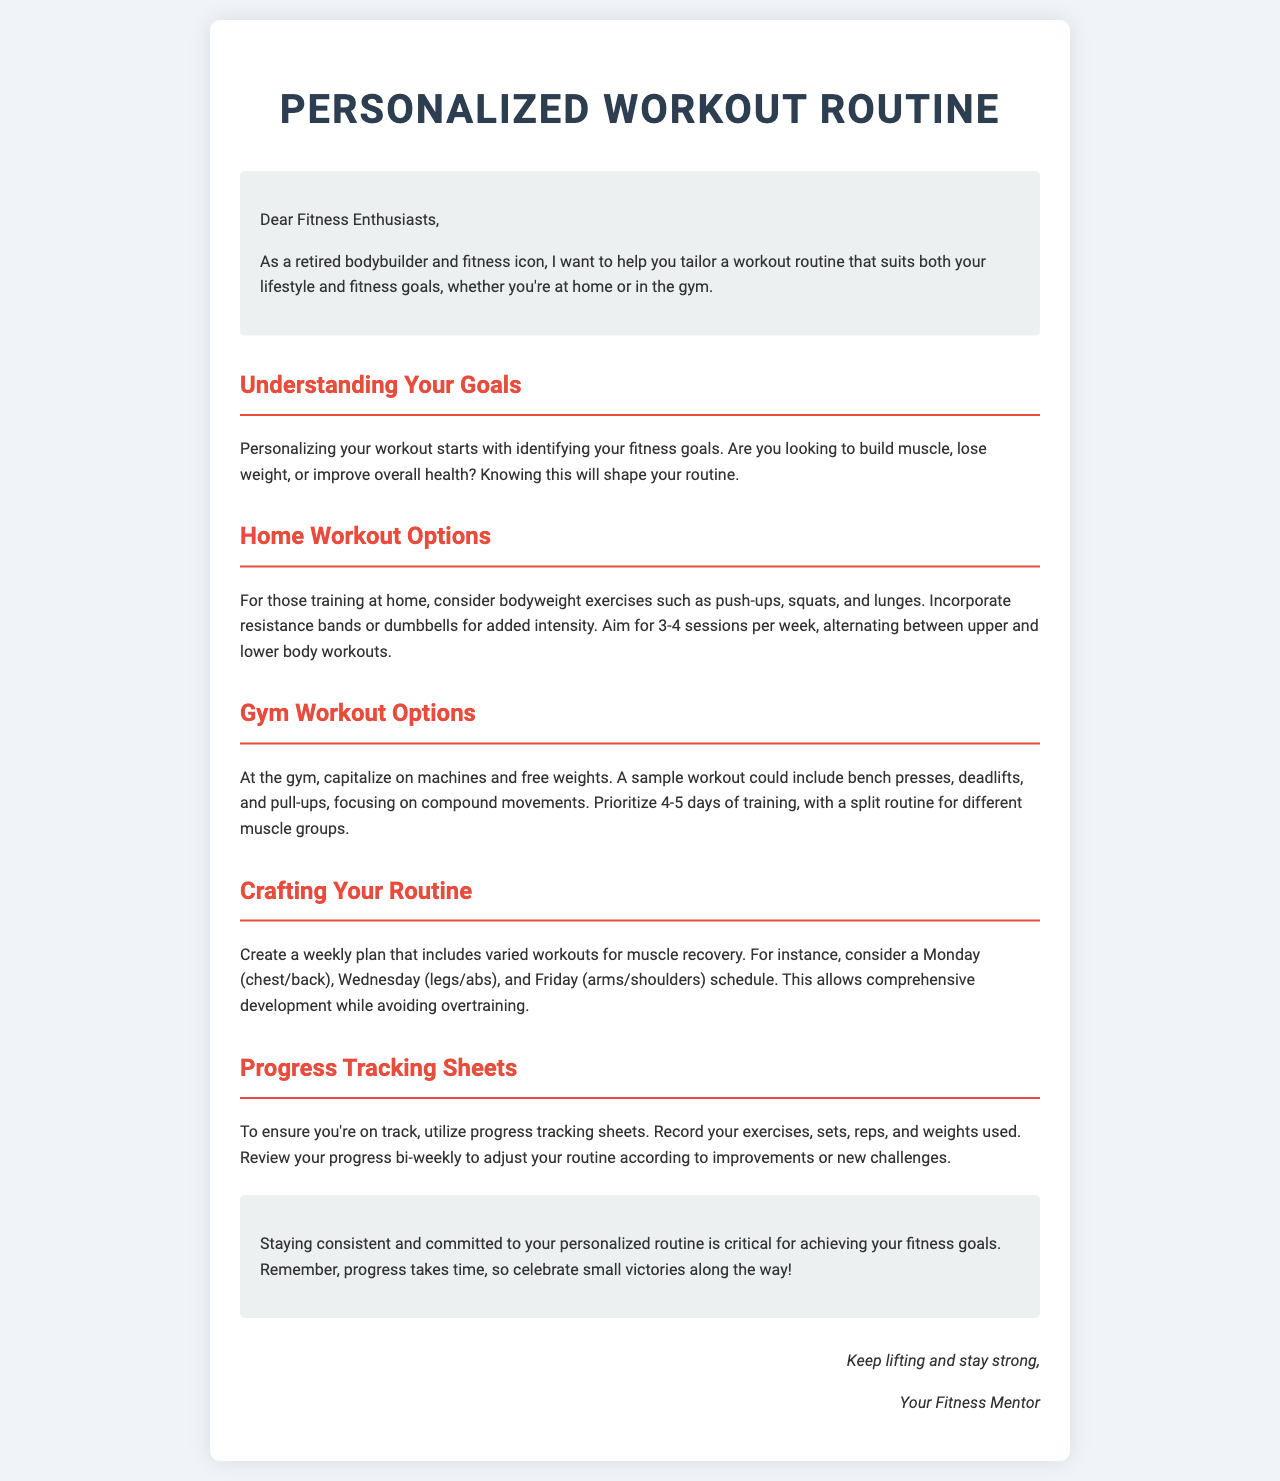What is the title of the document? The title of the document is provided in the header section of the HTML, which is "Personalized Workout Routine".
Answer: Personalized Workout Routine Who is the author of the letter? The author of the letter is mentioned in the signature, stating "Your Fitness Mentor".
Answer: Your Fitness Mentor How many days a week should you aim for home workouts? The document suggests aiming for 3-4 sessions per week for home workouts.
Answer: 3-4 What type of exercises are recommended for home workouts? The document lists bodyweight exercises such as push-ups, squats, and lunges as examples.
Answer: Bodyweight exercises What is a sample workout suggested for the gym? The document suggests bench presses, deadlifts, and pull-ups as part of a sample workout at the gym.
Answer: Bench presses, deadlifts, and pull-ups How often should progress be reviewed? The document advises to review progress bi-weekly to make adjustments to the routine.
Answer: Bi-weekly What is one example of a scheduled workout day mentioned? The document mentions a schedule including Monday for chest/back workouts.
Answer: Monday (chest/back) What is critical for achieving fitness goals according to the document? The document emphasizes that staying consistent and committed to the personalized routine is critical.
Answer: Consistency and commitment What should be recorded in the progress tracking sheets? The document states that exercises, sets, reps, and weights used should be recorded in the tracking sheets.
Answer: Exercises, sets, reps, and weights 